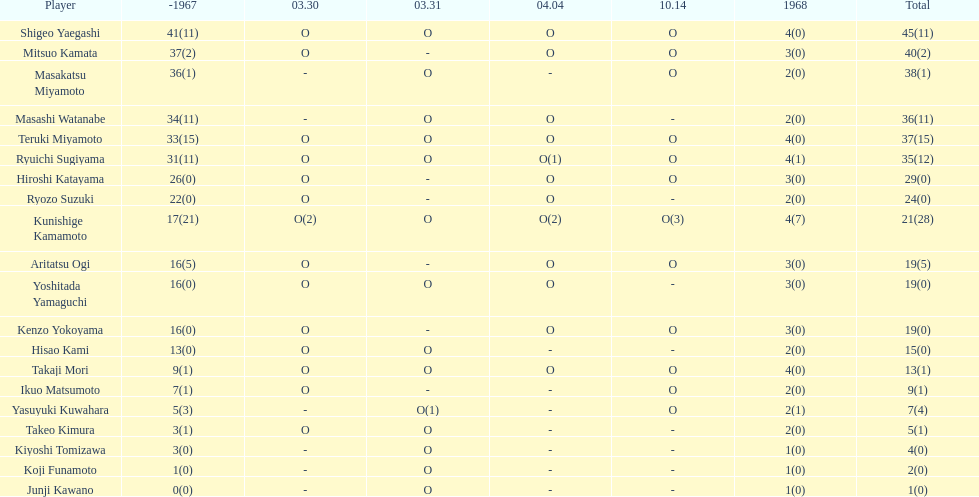What is the aggregate sum of mitsuo kamata's items? 40(2). 